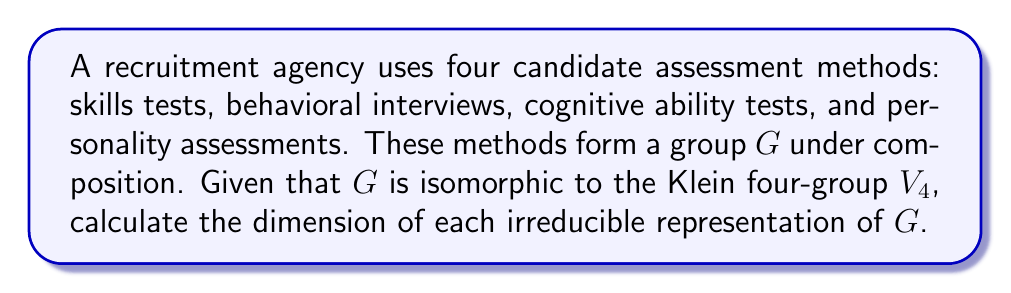Can you solve this math problem? To solve this problem, we'll follow these steps:

1) First, recall that the Klein four-group $V_4$ is an abelian group of order 4.

2) For abelian groups, all irreducible representations are one-dimensional. This is because the character of an irreducible representation of an abelian group is a homomorphism from the group to the multiplicative group of complex numbers.

3) The number of irreducible representations of a finite group is equal to the number of conjugacy classes. In an abelian group, each element forms its own conjugacy class.

4) The Klein four-group $V_4$ has 4 elements, so it has 4 irreducible representations.

5) The sum of the squares of the dimensions of the irreducible representations must equal the order of the group. Let's call the dimensions $d_1, d_2, d_3, d_4$. Then:

   $$d_1^2 + d_2^2 + d_3^2 + d_4^2 = |G| = 4$$

6) Given that all irreducible representations are one-dimensional, we have:

   $$1^2 + 1^2 + 1^2 + 1^2 = 4$$

Therefore, each of the four irreducible representations has dimension 1.
Answer: 1 